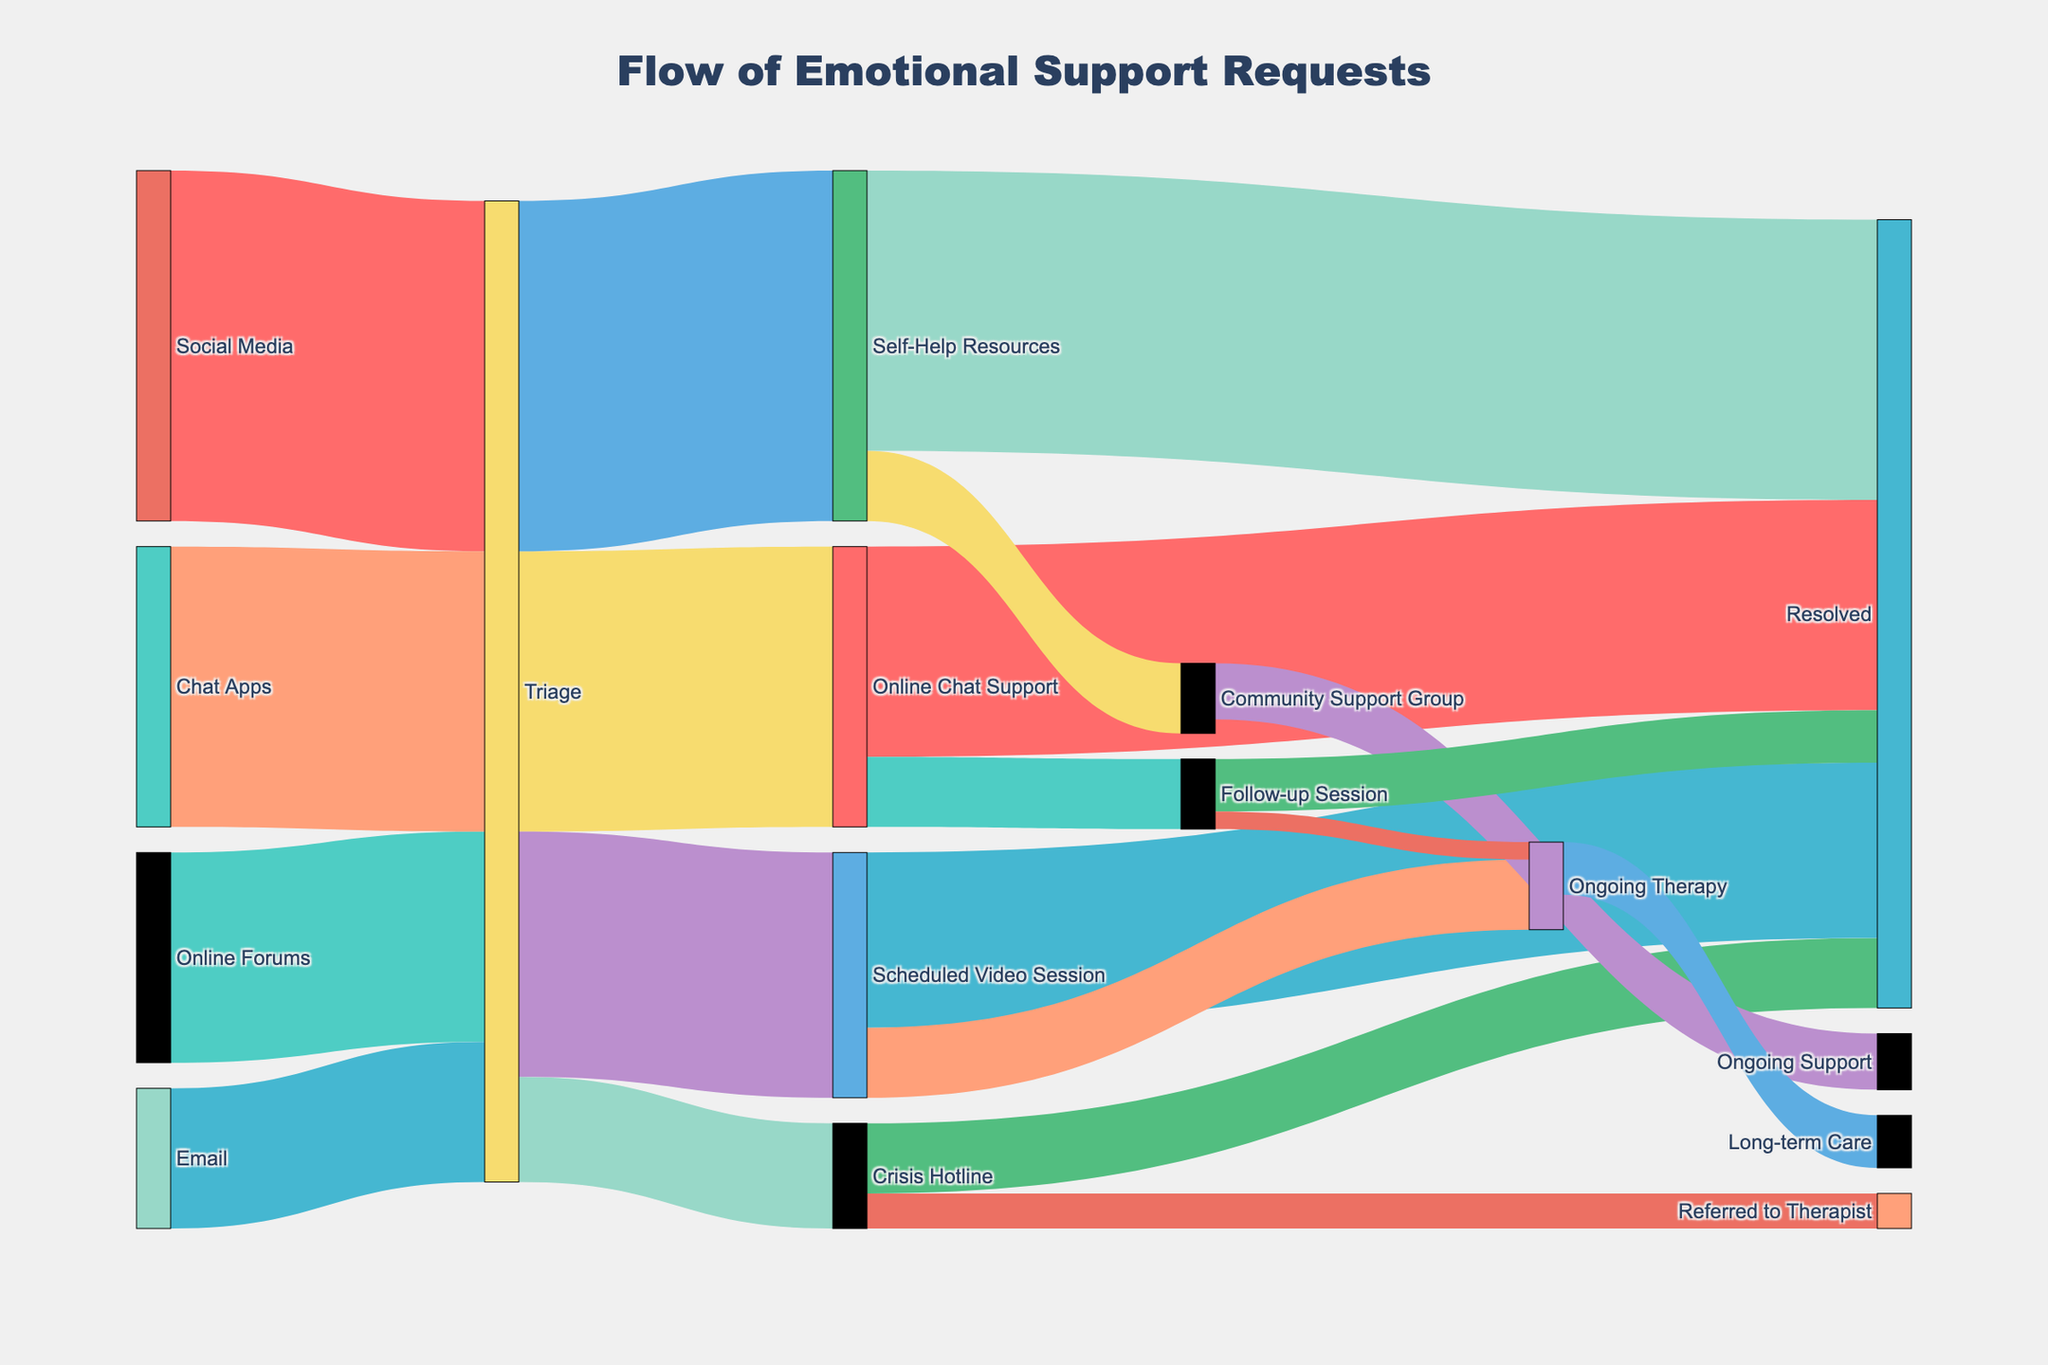what is the title of the figure? The title of the figure is displayed at the top and serves as a description of the entire Sankey diagram.
Answer: "Flow of Emotional Support Requests" How many channels feed into the Triage step? Identify the incoming flows to the 'Triage' node from their starting points ('Social Media', 'Online Forums', 'Email', 'Chat Apps').
Answer: 4 Which channel has the highest number of requests going to Triage? Compare the values (500, 300, 200, 400) for each channel ('Social Media', 'Online Forums', 'Email', 'Chat Apps') to identify the highest one.
Answer: Social Media Which resolution path handles the most requests after Triage? Analyze the target nodes from 'Triage' and their corresponding values (150, 400, 350, 500) to find the path with the highest value.
Answer: Self-Help Resources What is the total number of requests resolved directly from the initial steps to resolution? Sum the values leading directly to 'Resolved' from 'Crisis Hotline', 'Online Chat Support', 'Scheduled Video Session', and 'Self-Help Resources' (100 + 300 + 250 + 400).
Answer: 1050 How many requests are referred to a therapist from Crisis Hotline? Observe the connection from ‘Crisis Hotline’ to ‘Referred to Therapist’ and note its value.
Answer: 50 What is the value difference between requests channeled to Scheduled Video Sessions and Crisis Hotline from Triage? Compute the difference between values going from 'Triage' to 'Scheduled Video Session' (350) and 'Crisis Hotline' (150).
Answer: 200 How many requests required follow-up sessions from Online Chat Support? Check the value of the link between 'Online Chat Support' and 'Follow-up Session'.
Answer: 100 Which path has the lowest value flowing into the 'Resolved' status? Compare the values going directly to 'Resolved' (100, 300, 250, 400).
Answer: Crisis Hotline Total requests that proceed to ongoing care (Ongoing Therapy and Long-term Care) are how much? Add the values for 'Ongoing Therapy' (100) and 'Long-term Care' (75) from their respective sources.
Answer: 175 